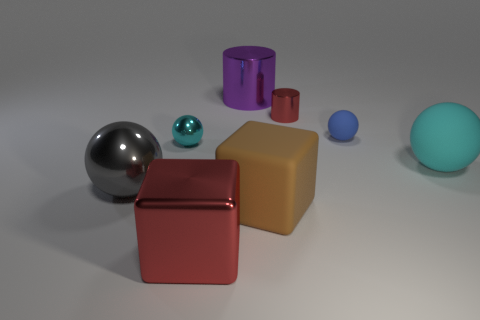Subtract all tiny metallic balls. How many balls are left? 3 Subtract all cylinders. How many objects are left? 6 Subtract 2 cylinders. How many cylinders are left? 0 Subtract all blue spheres. Subtract all gray blocks. How many spheres are left? 3 Subtract all red cubes. How many blue spheres are left? 1 Subtract all red objects. Subtract all tiny cylinders. How many objects are left? 5 Add 1 large brown blocks. How many large brown blocks are left? 2 Add 1 large red matte cylinders. How many large red matte cylinders exist? 1 Add 1 small blue things. How many objects exist? 9 Subtract all purple cylinders. How many cylinders are left? 1 